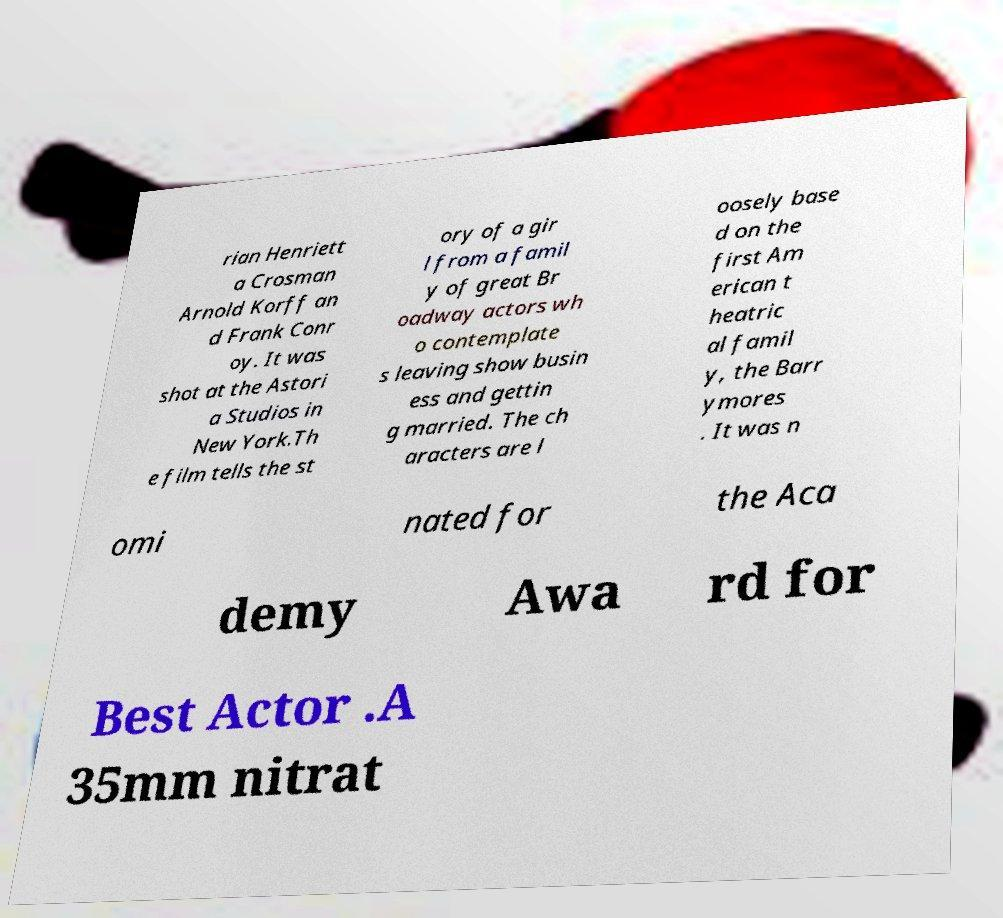I need the written content from this picture converted into text. Can you do that? rian Henriett a Crosman Arnold Korff an d Frank Conr oy. It was shot at the Astori a Studios in New York.Th e film tells the st ory of a gir l from a famil y of great Br oadway actors wh o contemplate s leaving show busin ess and gettin g married. The ch aracters are l oosely base d on the first Am erican t heatric al famil y, the Barr ymores . It was n omi nated for the Aca demy Awa rd for Best Actor .A 35mm nitrat 